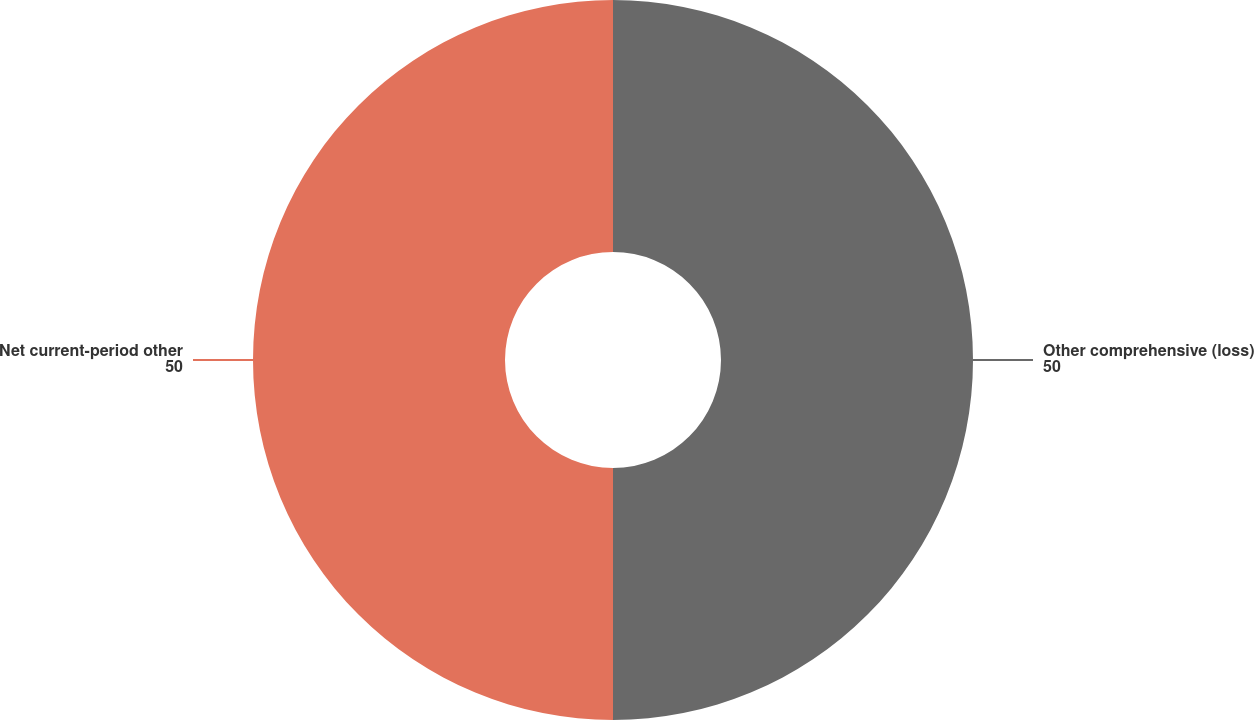Convert chart. <chart><loc_0><loc_0><loc_500><loc_500><pie_chart><fcel>Other comprehensive (loss)<fcel>Net current-period other<nl><fcel>50.0%<fcel>50.0%<nl></chart> 